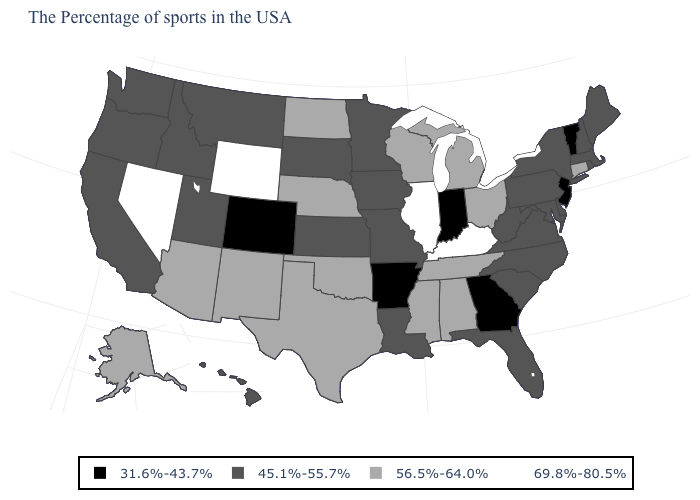Among the states that border Utah , does Colorado have the lowest value?
Be succinct. Yes. What is the value of Nebraska?
Keep it brief. 56.5%-64.0%. What is the value of Connecticut?
Be succinct. 56.5%-64.0%. Which states have the lowest value in the USA?
Quick response, please. Vermont, New Jersey, Georgia, Indiana, Arkansas, Colorado. What is the lowest value in states that border Idaho?
Quick response, please. 45.1%-55.7%. Does Nebraska have the lowest value in the MidWest?
Short answer required. No. Name the states that have a value in the range 45.1%-55.7%?
Give a very brief answer. Maine, Massachusetts, Rhode Island, New Hampshire, New York, Delaware, Maryland, Pennsylvania, Virginia, North Carolina, South Carolina, West Virginia, Florida, Louisiana, Missouri, Minnesota, Iowa, Kansas, South Dakota, Utah, Montana, Idaho, California, Washington, Oregon, Hawaii. What is the value of South Carolina?
Quick response, please. 45.1%-55.7%. What is the value of Georgia?
Quick response, please. 31.6%-43.7%. Which states hav the highest value in the Northeast?
Be succinct. Connecticut. Name the states that have a value in the range 45.1%-55.7%?
Quick response, please. Maine, Massachusetts, Rhode Island, New Hampshire, New York, Delaware, Maryland, Pennsylvania, Virginia, North Carolina, South Carolina, West Virginia, Florida, Louisiana, Missouri, Minnesota, Iowa, Kansas, South Dakota, Utah, Montana, Idaho, California, Washington, Oregon, Hawaii. Does Vermont have the same value as Montana?
Concise answer only. No. Name the states that have a value in the range 45.1%-55.7%?
Keep it brief. Maine, Massachusetts, Rhode Island, New Hampshire, New York, Delaware, Maryland, Pennsylvania, Virginia, North Carolina, South Carolina, West Virginia, Florida, Louisiana, Missouri, Minnesota, Iowa, Kansas, South Dakota, Utah, Montana, Idaho, California, Washington, Oregon, Hawaii. Which states have the highest value in the USA?
Write a very short answer. Kentucky, Illinois, Wyoming, Nevada. Name the states that have a value in the range 45.1%-55.7%?
Keep it brief. Maine, Massachusetts, Rhode Island, New Hampshire, New York, Delaware, Maryland, Pennsylvania, Virginia, North Carolina, South Carolina, West Virginia, Florida, Louisiana, Missouri, Minnesota, Iowa, Kansas, South Dakota, Utah, Montana, Idaho, California, Washington, Oregon, Hawaii. 